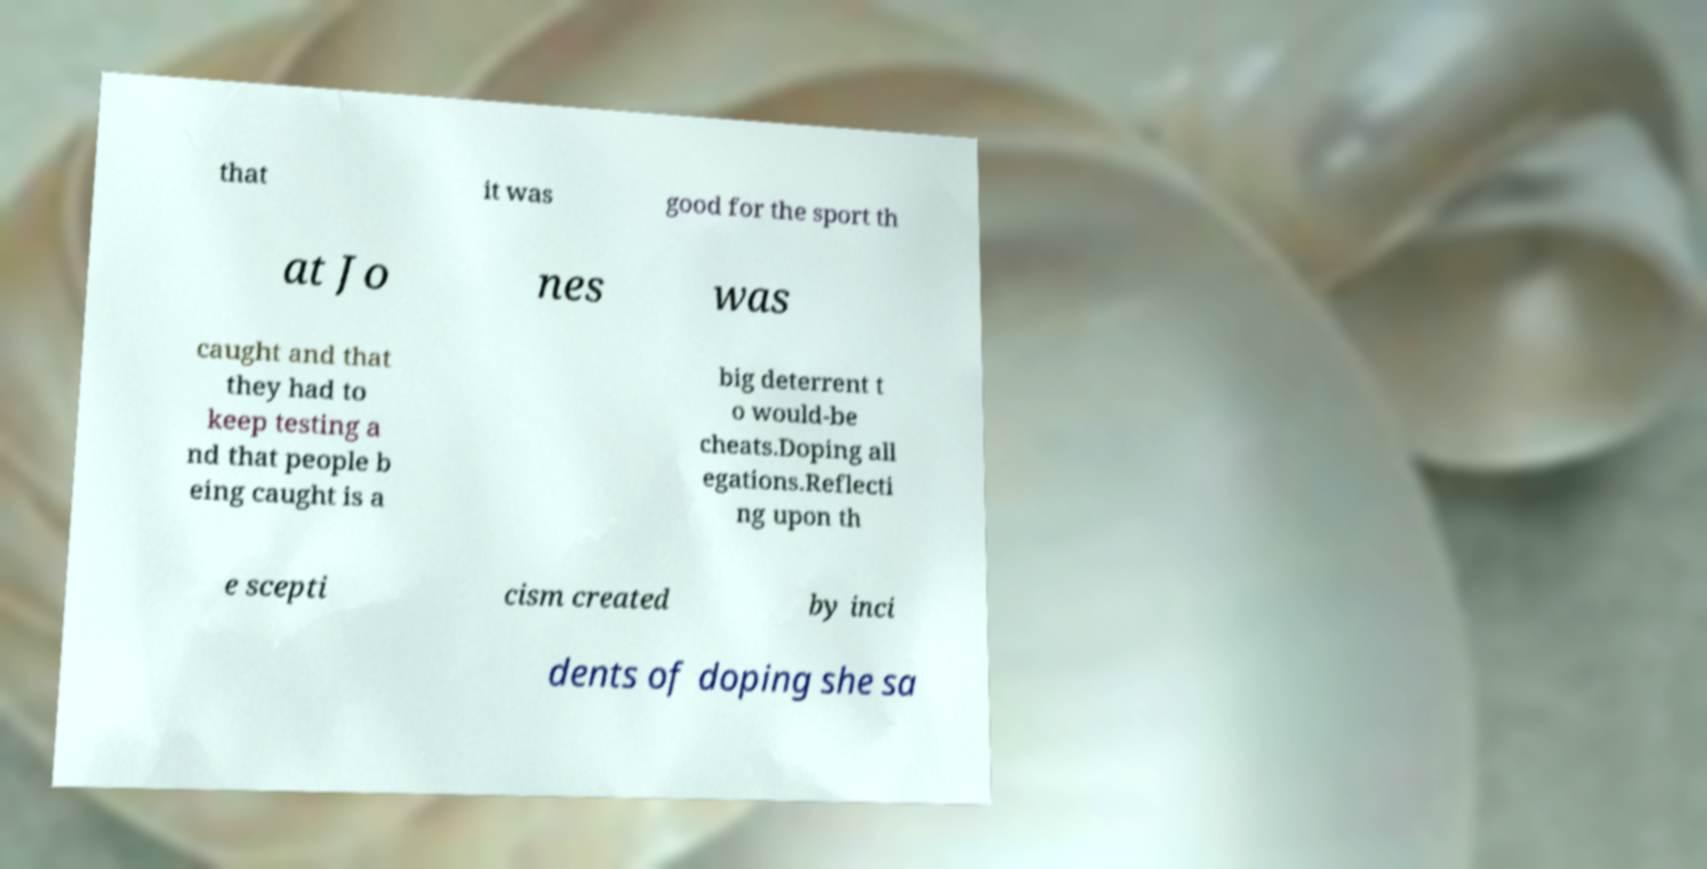There's text embedded in this image that I need extracted. Can you transcribe it verbatim? that it was good for the sport th at Jo nes was caught and that they had to keep testing a nd that people b eing caught is a big deterrent t o would-be cheats.Doping all egations.Reflecti ng upon th e scepti cism created by inci dents of doping she sa 